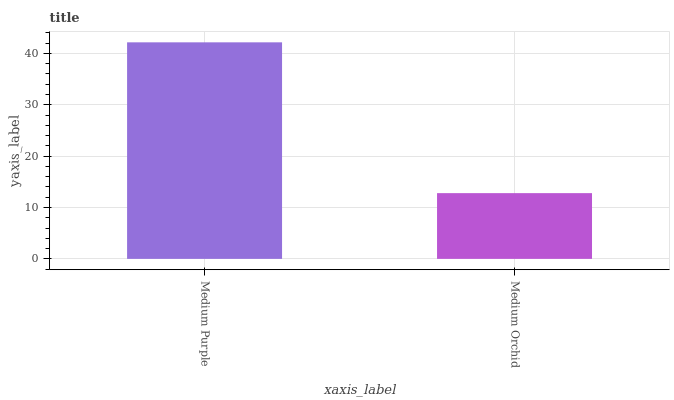Is Medium Orchid the minimum?
Answer yes or no. Yes. Is Medium Purple the maximum?
Answer yes or no. Yes. Is Medium Orchid the maximum?
Answer yes or no. No. Is Medium Purple greater than Medium Orchid?
Answer yes or no. Yes. Is Medium Orchid less than Medium Purple?
Answer yes or no. Yes. Is Medium Orchid greater than Medium Purple?
Answer yes or no. No. Is Medium Purple less than Medium Orchid?
Answer yes or no. No. Is Medium Purple the high median?
Answer yes or no. Yes. Is Medium Orchid the low median?
Answer yes or no. Yes. Is Medium Orchid the high median?
Answer yes or no. No. Is Medium Purple the low median?
Answer yes or no. No. 